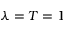<formula> <loc_0><loc_0><loc_500><loc_500>\lambda = T = 1</formula> 